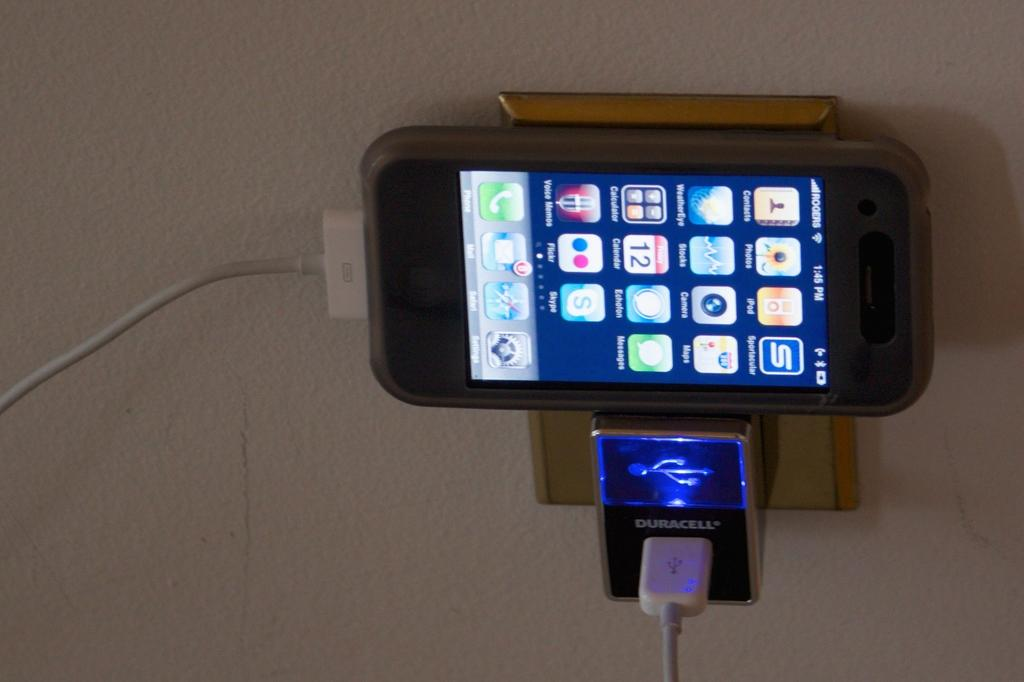<image>
Relay a brief, clear account of the picture shown. A cell phone is plugged into a Duracell charger. 